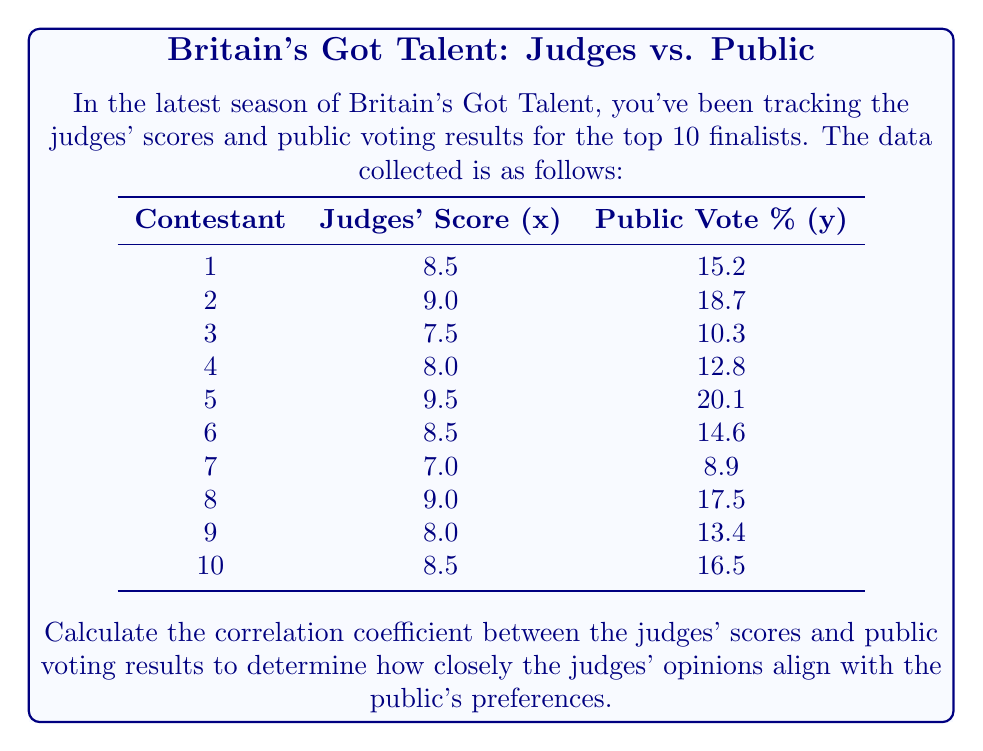What is the answer to this math problem? To calculate the correlation coefficient, we'll use the Pearson correlation coefficient formula:

$$r = \frac{\sum_{i=1}^{n} (x_i - \bar{x})(y_i - \bar{y})}{\sqrt{\sum_{i=1}^{n} (x_i - \bar{x})^2 \sum_{i=1}^{n} (y_i - \bar{y})^2}}$$

Where:
$x_i$ are the judges' scores
$y_i$ are the public vote percentages
$\bar{x}$ is the mean of judges' scores
$\bar{y}$ is the mean of public vote percentages

Step 1: Calculate the means
$\bar{x} = \frac{8.5 + 9.0 + 7.5 + 8.0 + 9.5 + 8.5 + 7.0 + 9.0 + 8.0 + 8.5}{10} = 8.35$
$\bar{y} = \frac{15.2 + 18.7 + 10.3 + 12.8 + 20.1 + 14.6 + 8.9 + 17.5 + 13.4 + 16.5}{10} = 14.8$

Step 2: Calculate $(x_i - \bar{x})$, $(y_i - \bar{y})$, $(x_i - \bar{x})^2$, $(y_i - \bar{y})^2$, and $(x_i - \bar{x})(y_i - \bar{y})$ for each contestant.

Step 3: Sum up the calculated values:
$\sum (x_i - \bar{x})(y_i - \bar{y}) = 21.915$
$\sum (x_i - \bar{x})^2 = 5.025$
$\sum (y_i - \bar{y})^2 = 128.66$

Step 4: Apply the formula:

$$r = \frac{21.915}{\sqrt{5.025 \times 128.66}} = \frac{21.915}{25.43} = 0.8618$$
Answer: $0.8618$ 